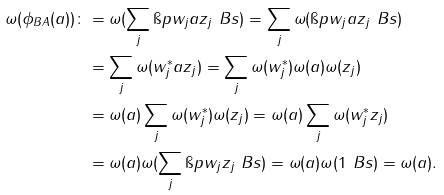Convert formula to latex. <formula><loc_0><loc_0><loc_500><loc_500>\omega ( \phi _ { B A } ( a ) ) \colon & = \omega ( \sum _ { j } \i p { w _ { j } } { a z _ { j } } _ { \ } B s ) = \sum _ { j } \omega ( \i p { w _ { j } } { a z _ { j } } _ { \ } B s ) \\ & = \sum _ { j } \omega ( w _ { j } ^ { * } a z _ { j } ) = \sum _ { j } \omega ( w _ { j } ^ { * } ) \omega ( a ) \omega ( z _ { j } ) \\ & = \omega ( a ) \sum _ { j } \omega ( w _ { j } ^ { * } ) \omega ( z _ { j } ) = \omega ( a ) \sum _ { j } \omega ( w _ { j } ^ { * } z _ { j } ) \\ & = \omega ( a ) \omega ( \sum _ { j } \i p { w _ { j } } { z _ { j } } _ { \ } B s ) = \omega ( a ) \omega ( 1 _ { \ } B s ) = \omega ( a ) .</formula> 